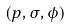Convert formula to latex. <formula><loc_0><loc_0><loc_500><loc_500>( p , \sigma , \phi )</formula> 